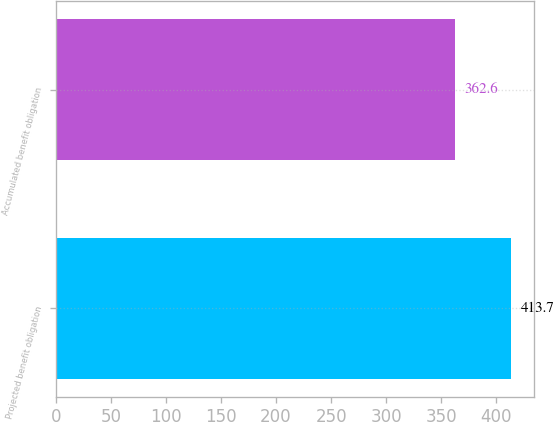Convert chart. <chart><loc_0><loc_0><loc_500><loc_500><bar_chart><fcel>Projected benefit obligation<fcel>Accumulated benefit obligation<nl><fcel>413.7<fcel>362.6<nl></chart> 